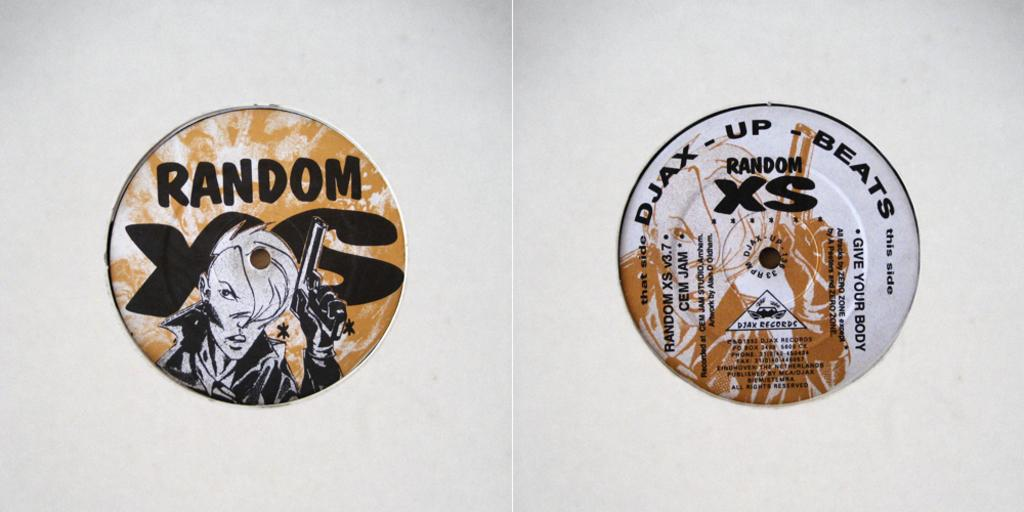Provide a one-sentence caption for the provided image. Two circle pieces say random and one has DJAX Up Beats at the top. 